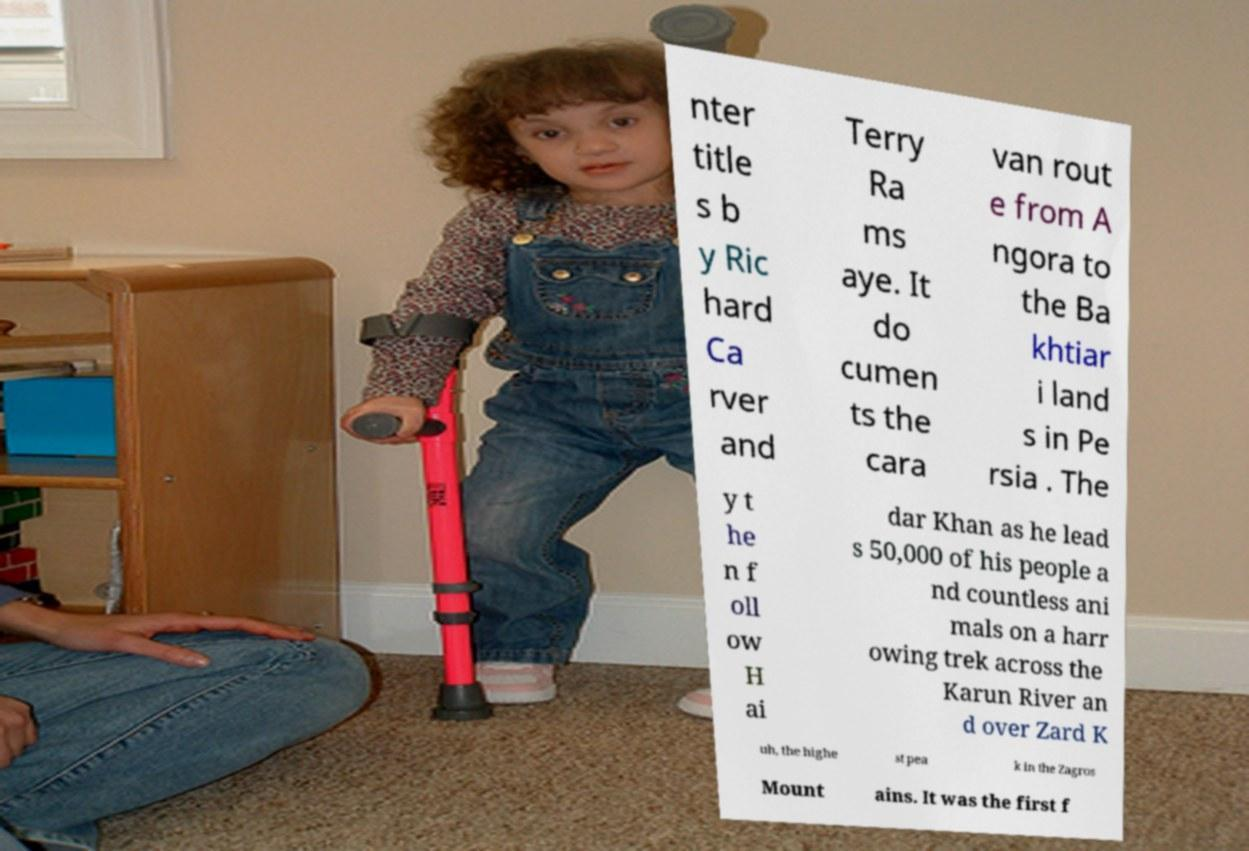What messages or text are displayed in this image? I need them in a readable, typed format. nter title s b y Ric hard Ca rver and Terry Ra ms aye. It do cumen ts the cara van rout e from A ngora to the Ba khtiar i land s in Pe rsia . The y t he n f oll ow H ai dar Khan as he lead s 50,000 of his people a nd countless ani mals on a harr owing trek across the Karun River an d over Zard K uh, the highe st pea k in the Zagros Mount ains. It was the first f 